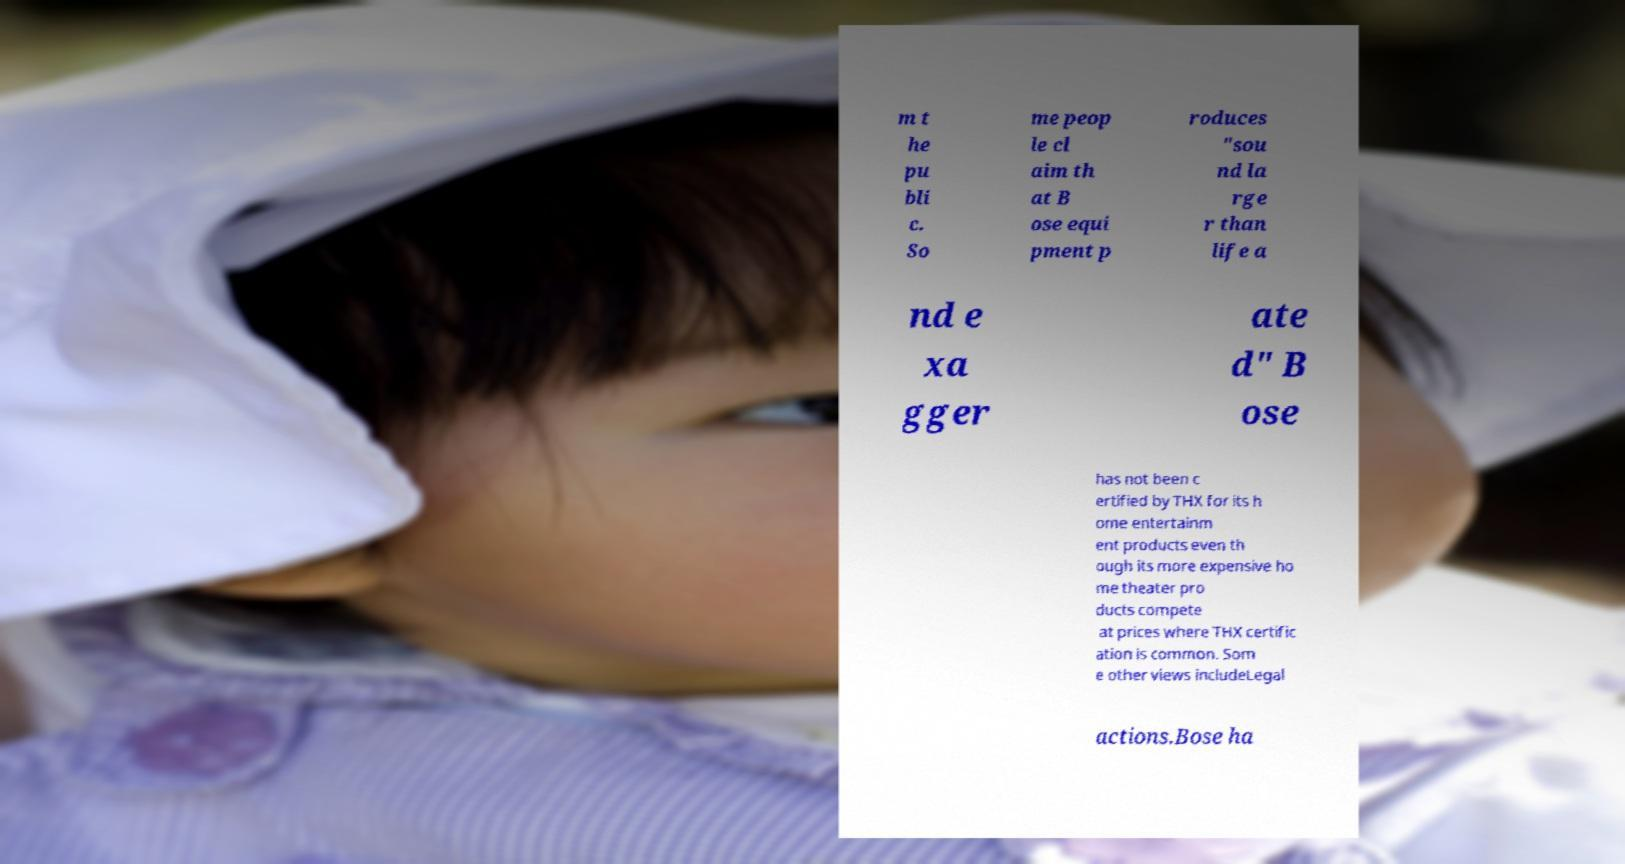Could you extract and type out the text from this image? m t he pu bli c. So me peop le cl aim th at B ose equi pment p roduces "sou nd la rge r than life a nd e xa gger ate d" B ose has not been c ertified by THX for its h ome entertainm ent products even th ough its more expensive ho me theater pro ducts compete at prices where THX certific ation is common. Som e other views includeLegal actions.Bose ha 